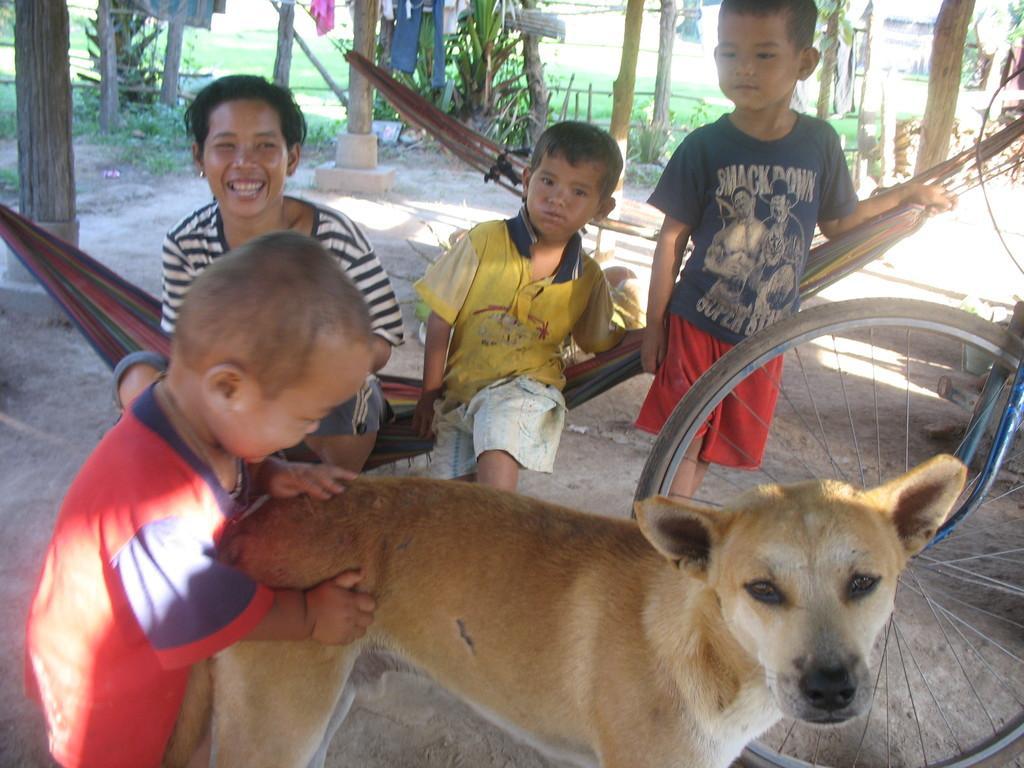Can you describe this image briefly? Here we can see four persons. There is a dog and this is swing. There is a wheel. Here we can see grass and there are plants. 